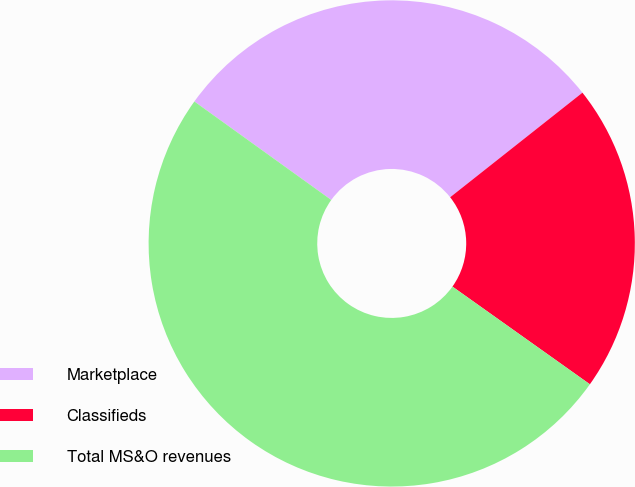Convert chart to OTSL. <chart><loc_0><loc_0><loc_500><loc_500><pie_chart><fcel>Marketplace<fcel>Classifieds<fcel>Total MS&O revenues<nl><fcel>29.43%<fcel>20.48%<fcel>50.09%<nl></chart> 